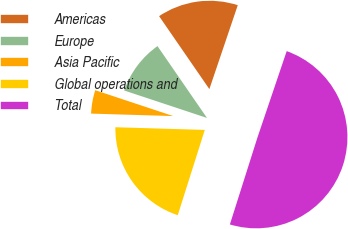Convert chart to OTSL. <chart><loc_0><loc_0><loc_500><loc_500><pie_chart><fcel>Americas<fcel>Europe<fcel>Asia Pacific<fcel>Global operations and<fcel>Total<nl><fcel>14.8%<fcel>10.3%<fcel>4.62%<fcel>20.59%<fcel>49.69%<nl></chart> 